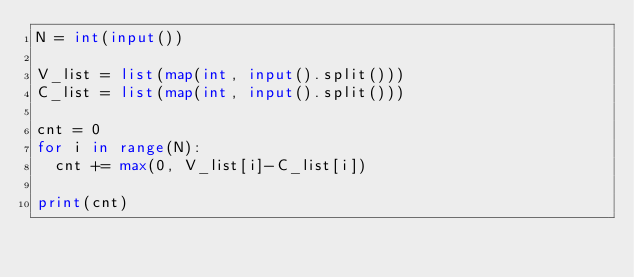Convert code to text. <code><loc_0><loc_0><loc_500><loc_500><_Python_>N = int(input())

V_list = list(map(int, input().split()))
C_list = list(map(int, input().split()))

cnt = 0
for i in range(N):
  cnt += max(0, V_list[i]-C_list[i])
  
print(cnt)</code> 